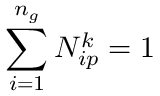Convert formula to latex. <formula><loc_0><loc_0><loc_500><loc_500>\sum _ { i = 1 } ^ { n _ { g } } N _ { i p } ^ { k } = 1</formula> 